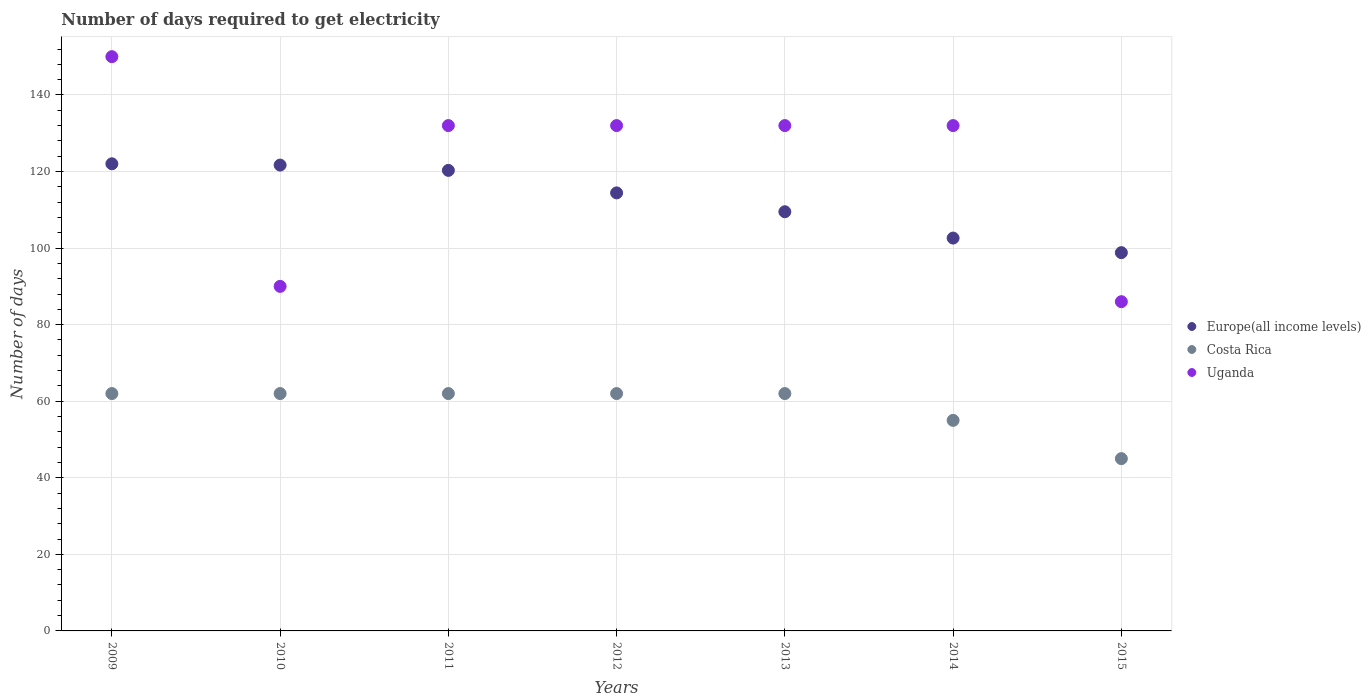What is the number of days required to get electricity in in Uganda in 2015?
Your answer should be compact. 86. Across all years, what is the maximum number of days required to get electricity in in Costa Rica?
Your response must be concise. 62. Across all years, what is the minimum number of days required to get electricity in in Europe(all income levels)?
Provide a short and direct response. 98.81. In which year was the number of days required to get electricity in in Uganda maximum?
Provide a short and direct response. 2009. In which year was the number of days required to get electricity in in Uganda minimum?
Keep it short and to the point. 2015. What is the total number of days required to get electricity in in Europe(all income levels) in the graph?
Your response must be concise. 789.33. What is the difference between the number of days required to get electricity in in Uganda in 2012 and that in 2013?
Provide a short and direct response. 0. What is the difference between the number of days required to get electricity in in Costa Rica in 2015 and the number of days required to get electricity in in Europe(all income levels) in 2010?
Offer a very short reply. -76.68. What is the average number of days required to get electricity in in Europe(all income levels) per year?
Provide a succinct answer. 112.76. In the year 2011, what is the difference between the number of days required to get electricity in in Uganda and number of days required to get electricity in in Costa Rica?
Offer a very short reply. 70. In how many years, is the number of days required to get electricity in in Costa Rica greater than 80 days?
Give a very brief answer. 0. What is the ratio of the number of days required to get electricity in in Uganda in 2010 to that in 2011?
Your answer should be compact. 0.68. Is the number of days required to get electricity in in Europe(all income levels) in 2011 less than that in 2012?
Keep it short and to the point. No. What is the difference between the highest and the second highest number of days required to get electricity in in Europe(all income levels)?
Ensure brevity in your answer.  0.34. What is the difference between the highest and the lowest number of days required to get electricity in in Europe(all income levels)?
Your answer should be very brief. 23.22. Is the sum of the number of days required to get electricity in in Europe(all income levels) in 2009 and 2014 greater than the maximum number of days required to get electricity in in Costa Rica across all years?
Your answer should be very brief. Yes. Is it the case that in every year, the sum of the number of days required to get electricity in in Costa Rica and number of days required to get electricity in in Europe(all income levels)  is greater than the number of days required to get electricity in in Uganda?
Your response must be concise. Yes. Does the number of days required to get electricity in in Uganda monotonically increase over the years?
Make the answer very short. No. How many years are there in the graph?
Your answer should be compact. 7. Are the values on the major ticks of Y-axis written in scientific E-notation?
Offer a terse response. No. Does the graph contain any zero values?
Your response must be concise. No. Where does the legend appear in the graph?
Your response must be concise. Center right. How are the legend labels stacked?
Ensure brevity in your answer.  Vertical. What is the title of the graph?
Make the answer very short. Number of days required to get electricity. What is the label or title of the Y-axis?
Your answer should be compact. Number of days. What is the Number of days of Europe(all income levels) in 2009?
Offer a very short reply. 122.02. What is the Number of days of Costa Rica in 2009?
Your answer should be compact. 62. What is the Number of days of Uganda in 2009?
Give a very brief answer. 150. What is the Number of days of Europe(all income levels) in 2010?
Give a very brief answer. 121.68. What is the Number of days of Costa Rica in 2010?
Provide a short and direct response. 62. What is the Number of days of Uganda in 2010?
Ensure brevity in your answer.  90. What is the Number of days of Europe(all income levels) in 2011?
Your answer should be very brief. 120.3. What is the Number of days in Costa Rica in 2011?
Make the answer very short. 62. What is the Number of days of Uganda in 2011?
Offer a very short reply. 132. What is the Number of days in Europe(all income levels) in 2012?
Provide a succinct answer. 114.42. What is the Number of days of Uganda in 2012?
Offer a terse response. 132. What is the Number of days in Europe(all income levels) in 2013?
Make the answer very short. 109.49. What is the Number of days of Costa Rica in 2013?
Provide a short and direct response. 62. What is the Number of days in Uganda in 2013?
Provide a short and direct response. 132. What is the Number of days in Europe(all income levels) in 2014?
Keep it short and to the point. 102.62. What is the Number of days of Costa Rica in 2014?
Your answer should be very brief. 55. What is the Number of days in Uganda in 2014?
Keep it short and to the point. 132. What is the Number of days in Europe(all income levels) in 2015?
Ensure brevity in your answer.  98.81. What is the Number of days of Uganda in 2015?
Your response must be concise. 86. Across all years, what is the maximum Number of days of Europe(all income levels)?
Ensure brevity in your answer.  122.02. Across all years, what is the maximum Number of days in Costa Rica?
Your answer should be very brief. 62. Across all years, what is the maximum Number of days of Uganda?
Provide a short and direct response. 150. Across all years, what is the minimum Number of days in Europe(all income levels)?
Your response must be concise. 98.81. Across all years, what is the minimum Number of days of Costa Rica?
Offer a terse response. 45. What is the total Number of days of Europe(all income levels) in the graph?
Your answer should be very brief. 789.33. What is the total Number of days of Costa Rica in the graph?
Keep it short and to the point. 410. What is the total Number of days in Uganda in the graph?
Provide a short and direct response. 854. What is the difference between the Number of days in Europe(all income levels) in 2009 and that in 2010?
Keep it short and to the point. 0.34. What is the difference between the Number of days of Costa Rica in 2009 and that in 2010?
Offer a very short reply. 0. What is the difference between the Number of days of Europe(all income levels) in 2009 and that in 2011?
Give a very brief answer. 1.72. What is the difference between the Number of days of Uganda in 2009 and that in 2011?
Provide a short and direct response. 18. What is the difference between the Number of days in Europe(all income levels) in 2009 and that in 2012?
Ensure brevity in your answer.  7.6. What is the difference between the Number of days in Europe(all income levels) in 2009 and that in 2013?
Ensure brevity in your answer.  12.53. What is the difference between the Number of days in Costa Rica in 2009 and that in 2013?
Offer a terse response. 0. What is the difference between the Number of days of Uganda in 2009 and that in 2013?
Your answer should be very brief. 18. What is the difference between the Number of days in Europe(all income levels) in 2009 and that in 2014?
Give a very brief answer. 19.41. What is the difference between the Number of days in Europe(all income levels) in 2009 and that in 2015?
Ensure brevity in your answer.  23.22. What is the difference between the Number of days in Europe(all income levels) in 2010 and that in 2011?
Offer a terse response. 1.38. What is the difference between the Number of days in Uganda in 2010 and that in 2011?
Keep it short and to the point. -42. What is the difference between the Number of days in Europe(all income levels) in 2010 and that in 2012?
Ensure brevity in your answer.  7.26. What is the difference between the Number of days in Costa Rica in 2010 and that in 2012?
Offer a terse response. 0. What is the difference between the Number of days in Uganda in 2010 and that in 2012?
Your answer should be compact. -42. What is the difference between the Number of days of Europe(all income levels) in 2010 and that in 2013?
Your response must be concise. 12.19. What is the difference between the Number of days in Costa Rica in 2010 and that in 2013?
Make the answer very short. 0. What is the difference between the Number of days of Uganda in 2010 and that in 2013?
Your answer should be compact. -42. What is the difference between the Number of days in Europe(all income levels) in 2010 and that in 2014?
Your answer should be very brief. 19.06. What is the difference between the Number of days in Uganda in 2010 and that in 2014?
Provide a short and direct response. -42. What is the difference between the Number of days in Europe(all income levels) in 2010 and that in 2015?
Provide a succinct answer. 22.87. What is the difference between the Number of days in Costa Rica in 2010 and that in 2015?
Offer a very short reply. 17. What is the difference between the Number of days in Europe(all income levels) in 2011 and that in 2012?
Provide a succinct answer. 5.88. What is the difference between the Number of days in Costa Rica in 2011 and that in 2012?
Provide a short and direct response. 0. What is the difference between the Number of days of Uganda in 2011 and that in 2012?
Keep it short and to the point. 0. What is the difference between the Number of days in Europe(all income levels) in 2011 and that in 2013?
Your answer should be compact. 10.8. What is the difference between the Number of days of Costa Rica in 2011 and that in 2013?
Keep it short and to the point. 0. What is the difference between the Number of days in Uganda in 2011 and that in 2013?
Ensure brevity in your answer.  0. What is the difference between the Number of days of Europe(all income levels) in 2011 and that in 2014?
Keep it short and to the point. 17.68. What is the difference between the Number of days in Costa Rica in 2011 and that in 2014?
Ensure brevity in your answer.  7. What is the difference between the Number of days of Uganda in 2011 and that in 2014?
Provide a succinct answer. 0. What is the difference between the Number of days in Europe(all income levels) in 2011 and that in 2015?
Keep it short and to the point. 21.49. What is the difference between the Number of days in Costa Rica in 2011 and that in 2015?
Make the answer very short. 17. What is the difference between the Number of days in Europe(all income levels) in 2012 and that in 2013?
Provide a short and direct response. 4.92. What is the difference between the Number of days of Costa Rica in 2012 and that in 2013?
Your response must be concise. 0. What is the difference between the Number of days in Uganda in 2012 and that in 2013?
Offer a terse response. 0. What is the difference between the Number of days of Europe(all income levels) in 2012 and that in 2014?
Offer a very short reply. 11.8. What is the difference between the Number of days in Costa Rica in 2012 and that in 2014?
Your answer should be very brief. 7. What is the difference between the Number of days of Uganda in 2012 and that in 2014?
Your answer should be compact. 0. What is the difference between the Number of days in Europe(all income levels) in 2012 and that in 2015?
Your response must be concise. 15.61. What is the difference between the Number of days of Uganda in 2012 and that in 2015?
Your answer should be compact. 46. What is the difference between the Number of days in Europe(all income levels) in 2013 and that in 2014?
Ensure brevity in your answer.  6.88. What is the difference between the Number of days in Europe(all income levels) in 2013 and that in 2015?
Your response must be concise. 10.69. What is the difference between the Number of days in Costa Rica in 2013 and that in 2015?
Your answer should be very brief. 17. What is the difference between the Number of days in Europe(all income levels) in 2014 and that in 2015?
Your answer should be very brief. 3.81. What is the difference between the Number of days of Costa Rica in 2014 and that in 2015?
Provide a succinct answer. 10. What is the difference between the Number of days of Uganda in 2014 and that in 2015?
Keep it short and to the point. 46. What is the difference between the Number of days in Europe(all income levels) in 2009 and the Number of days in Costa Rica in 2010?
Provide a succinct answer. 60.02. What is the difference between the Number of days of Europe(all income levels) in 2009 and the Number of days of Uganda in 2010?
Keep it short and to the point. 32.02. What is the difference between the Number of days of Costa Rica in 2009 and the Number of days of Uganda in 2010?
Offer a terse response. -28. What is the difference between the Number of days of Europe(all income levels) in 2009 and the Number of days of Costa Rica in 2011?
Offer a very short reply. 60.02. What is the difference between the Number of days in Europe(all income levels) in 2009 and the Number of days in Uganda in 2011?
Keep it short and to the point. -9.98. What is the difference between the Number of days of Costa Rica in 2009 and the Number of days of Uganda in 2011?
Give a very brief answer. -70. What is the difference between the Number of days in Europe(all income levels) in 2009 and the Number of days in Costa Rica in 2012?
Offer a terse response. 60.02. What is the difference between the Number of days of Europe(all income levels) in 2009 and the Number of days of Uganda in 2012?
Your answer should be very brief. -9.98. What is the difference between the Number of days of Costa Rica in 2009 and the Number of days of Uganda in 2012?
Your answer should be compact. -70. What is the difference between the Number of days in Europe(all income levels) in 2009 and the Number of days in Costa Rica in 2013?
Make the answer very short. 60.02. What is the difference between the Number of days in Europe(all income levels) in 2009 and the Number of days in Uganda in 2013?
Give a very brief answer. -9.98. What is the difference between the Number of days in Costa Rica in 2009 and the Number of days in Uganda in 2013?
Your response must be concise. -70. What is the difference between the Number of days of Europe(all income levels) in 2009 and the Number of days of Costa Rica in 2014?
Give a very brief answer. 67.02. What is the difference between the Number of days in Europe(all income levels) in 2009 and the Number of days in Uganda in 2014?
Keep it short and to the point. -9.98. What is the difference between the Number of days in Costa Rica in 2009 and the Number of days in Uganda in 2014?
Ensure brevity in your answer.  -70. What is the difference between the Number of days of Europe(all income levels) in 2009 and the Number of days of Costa Rica in 2015?
Offer a terse response. 77.02. What is the difference between the Number of days in Europe(all income levels) in 2009 and the Number of days in Uganda in 2015?
Give a very brief answer. 36.02. What is the difference between the Number of days of Costa Rica in 2009 and the Number of days of Uganda in 2015?
Your response must be concise. -24. What is the difference between the Number of days in Europe(all income levels) in 2010 and the Number of days in Costa Rica in 2011?
Offer a very short reply. 59.68. What is the difference between the Number of days of Europe(all income levels) in 2010 and the Number of days of Uganda in 2011?
Your answer should be compact. -10.32. What is the difference between the Number of days of Costa Rica in 2010 and the Number of days of Uganda in 2011?
Your answer should be very brief. -70. What is the difference between the Number of days of Europe(all income levels) in 2010 and the Number of days of Costa Rica in 2012?
Make the answer very short. 59.68. What is the difference between the Number of days in Europe(all income levels) in 2010 and the Number of days in Uganda in 2012?
Provide a succinct answer. -10.32. What is the difference between the Number of days of Costa Rica in 2010 and the Number of days of Uganda in 2012?
Your response must be concise. -70. What is the difference between the Number of days of Europe(all income levels) in 2010 and the Number of days of Costa Rica in 2013?
Offer a terse response. 59.68. What is the difference between the Number of days in Europe(all income levels) in 2010 and the Number of days in Uganda in 2013?
Provide a succinct answer. -10.32. What is the difference between the Number of days of Costa Rica in 2010 and the Number of days of Uganda in 2013?
Offer a very short reply. -70. What is the difference between the Number of days in Europe(all income levels) in 2010 and the Number of days in Costa Rica in 2014?
Ensure brevity in your answer.  66.68. What is the difference between the Number of days of Europe(all income levels) in 2010 and the Number of days of Uganda in 2014?
Your answer should be compact. -10.32. What is the difference between the Number of days of Costa Rica in 2010 and the Number of days of Uganda in 2014?
Ensure brevity in your answer.  -70. What is the difference between the Number of days of Europe(all income levels) in 2010 and the Number of days of Costa Rica in 2015?
Give a very brief answer. 76.68. What is the difference between the Number of days in Europe(all income levels) in 2010 and the Number of days in Uganda in 2015?
Provide a short and direct response. 35.68. What is the difference between the Number of days in Costa Rica in 2010 and the Number of days in Uganda in 2015?
Your response must be concise. -24. What is the difference between the Number of days in Europe(all income levels) in 2011 and the Number of days in Costa Rica in 2012?
Your response must be concise. 58.3. What is the difference between the Number of days in Europe(all income levels) in 2011 and the Number of days in Uganda in 2012?
Your answer should be very brief. -11.7. What is the difference between the Number of days in Costa Rica in 2011 and the Number of days in Uganda in 2012?
Your answer should be compact. -70. What is the difference between the Number of days of Europe(all income levels) in 2011 and the Number of days of Costa Rica in 2013?
Your answer should be compact. 58.3. What is the difference between the Number of days in Europe(all income levels) in 2011 and the Number of days in Uganda in 2013?
Your response must be concise. -11.7. What is the difference between the Number of days in Costa Rica in 2011 and the Number of days in Uganda in 2013?
Offer a very short reply. -70. What is the difference between the Number of days in Europe(all income levels) in 2011 and the Number of days in Costa Rica in 2014?
Provide a succinct answer. 65.3. What is the difference between the Number of days of Europe(all income levels) in 2011 and the Number of days of Uganda in 2014?
Provide a succinct answer. -11.7. What is the difference between the Number of days in Costa Rica in 2011 and the Number of days in Uganda in 2014?
Make the answer very short. -70. What is the difference between the Number of days in Europe(all income levels) in 2011 and the Number of days in Costa Rica in 2015?
Keep it short and to the point. 75.3. What is the difference between the Number of days of Europe(all income levels) in 2011 and the Number of days of Uganda in 2015?
Provide a succinct answer. 34.3. What is the difference between the Number of days in Costa Rica in 2011 and the Number of days in Uganda in 2015?
Your answer should be very brief. -24. What is the difference between the Number of days of Europe(all income levels) in 2012 and the Number of days of Costa Rica in 2013?
Offer a terse response. 52.42. What is the difference between the Number of days of Europe(all income levels) in 2012 and the Number of days of Uganda in 2013?
Your answer should be very brief. -17.58. What is the difference between the Number of days of Costa Rica in 2012 and the Number of days of Uganda in 2013?
Provide a succinct answer. -70. What is the difference between the Number of days of Europe(all income levels) in 2012 and the Number of days of Costa Rica in 2014?
Give a very brief answer. 59.42. What is the difference between the Number of days of Europe(all income levels) in 2012 and the Number of days of Uganda in 2014?
Provide a succinct answer. -17.58. What is the difference between the Number of days in Costa Rica in 2012 and the Number of days in Uganda in 2014?
Provide a short and direct response. -70. What is the difference between the Number of days of Europe(all income levels) in 2012 and the Number of days of Costa Rica in 2015?
Your answer should be compact. 69.42. What is the difference between the Number of days in Europe(all income levels) in 2012 and the Number of days in Uganda in 2015?
Provide a short and direct response. 28.42. What is the difference between the Number of days in Europe(all income levels) in 2013 and the Number of days in Costa Rica in 2014?
Ensure brevity in your answer.  54.49. What is the difference between the Number of days in Europe(all income levels) in 2013 and the Number of days in Uganda in 2014?
Offer a terse response. -22.51. What is the difference between the Number of days of Costa Rica in 2013 and the Number of days of Uganda in 2014?
Provide a short and direct response. -70. What is the difference between the Number of days in Europe(all income levels) in 2013 and the Number of days in Costa Rica in 2015?
Offer a very short reply. 64.49. What is the difference between the Number of days in Europe(all income levels) in 2013 and the Number of days in Uganda in 2015?
Ensure brevity in your answer.  23.49. What is the difference between the Number of days of Costa Rica in 2013 and the Number of days of Uganda in 2015?
Provide a succinct answer. -24. What is the difference between the Number of days in Europe(all income levels) in 2014 and the Number of days in Costa Rica in 2015?
Provide a short and direct response. 57.62. What is the difference between the Number of days in Europe(all income levels) in 2014 and the Number of days in Uganda in 2015?
Offer a very short reply. 16.62. What is the difference between the Number of days of Costa Rica in 2014 and the Number of days of Uganda in 2015?
Make the answer very short. -31. What is the average Number of days of Europe(all income levels) per year?
Keep it short and to the point. 112.76. What is the average Number of days in Costa Rica per year?
Make the answer very short. 58.57. What is the average Number of days of Uganda per year?
Your response must be concise. 122. In the year 2009, what is the difference between the Number of days in Europe(all income levels) and Number of days in Costa Rica?
Your response must be concise. 60.02. In the year 2009, what is the difference between the Number of days of Europe(all income levels) and Number of days of Uganda?
Give a very brief answer. -27.98. In the year 2009, what is the difference between the Number of days in Costa Rica and Number of days in Uganda?
Your answer should be compact. -88. In the year 2010, what is the difference between the Number of days of Europe(all income levels) and Number of days of Costa Rica?
Your answer should be very brief. 59.68. In the year 2010, what is the difference between the Number of days of Europe(all income levels) and Number of days of Uganda?
Offer a terse response. 31.68. In the year 2010, what is the difference between the Number of days of Costa Rica and Number of days of Uganda?
Your answer should be compact. -28. In the year 2011, what is the difference between the Number of days in Europe(all income levels) and Number of days in Costa Rica?
Give a very brief answer. 58.3. In the year 2011, what is the difference between the Number of days in Europe(all income levels) and Number of days in Uganda?
Your answer should be compact. -11.7. In the year 2011, what is the difference between the Number of days in Costa Rica and Number of days in Uganda?
Your answer should be compact. -70. In the year 2012, what is the difference between the Number of days of Europe(all income levels) and Number of days of Costa Rica?
Offer a terse response. 52.42. In the year 2012, what is the difference between the Number of days of Europe(all income levels) and Number of days of Uganda?
Your answer should be very brief. -17.58. In the year 2012, what is the difference between the Number of days in Costa Rica and Number of days in Uganda?
Your response must be concise. -70. In the year 2013, what is the difference between the Number of days of Europe(all income levels) and Number of days of Costa Rica?
Your answer should be very brief. 47.49. In the year 2013, what is the difference between the Number of days of Europe(all income levels) and Number of days of Uganda?
Ensure brevity in your answer.  -22.51. In the year 2013, what is the difference between the Number of days in Costa Rica and Number of days in Uganda?
Your response must be concise. -70. In the year 2014, what is the difference between the Number of days in Europe(all income levels) and Number of days in Costa Rica?
Make the answer very short. 47.62. In the year 2014, what is the difference between the Number of days of Europe(all income levels) and Number of days of Uganda?
Give a very brief answer. -29.38. In the year 2014, what is the difference between the Number of days of Costa Rica and Number of days of Uganda?
Offer a very short reply. -77. In the year 2015, what is the difference between the Number of days of Europe(all income levels) and Number of days of Costa Rica?
Your response must be concise. 53.81. In the year 2015, what is the difference between the Number of days of Europe(all income levels) and Number of days of Uganda?
Make the answer very short. 12.81. In the year 2015, what is the difference between the Number of days in Costa Rica and Number of days in Uganda?
Provide a short and direct response. -41. What is the ratio of the Number of days of Europe(all income levels) in 2009 to that in 2010?
Give a very brief answer. 1. What is the ratio of the Number of days of Costa Rica in 2009 to that in 2010?
Make the answer very short. 1. What is the ratio of the Number of days in Uganda in 2009 to that in 2010?
Offer a very short reply. 1.67. What is the ratio of the Number of days of Europe(all income levels) in 2009 to that in 2011?
Keep it short and to the point. 1.01. What is the ratio of the Number of days of Costa Rica in 2009 to that in 2011?
Provide a succinct answer. 1. What is the ratio of the Number of days in Uganda in 2009 to that in 2011?
Your answer should be compact. 1.14. What is the ratio of the Number of days of Europe(all income levels) in 2009 to that in 2012?
Give a very brief answer. 1.07. What is the ratio of the Number of days in Uganda in 2009 to that in 2012?
Offer a very short reply. 1.14. What is the ratio of the Number of days in Europe(all income levels) in 2009 to that in 2013?
Your response must be concise. 1.11. What is the ratio of the Number of days of Uganda in 2009 to that in 2013?
Provide a short and direct response. 1.14. What is the ratio of the Number of days of Europe(all income levels) in 2009 to that in 2014?
Ensure brevity in your answer.  1.19. What is the ratio of the Number of days in Costa Rica in 2009 to that in 2014?
Ensure brevity in your answer.  1.13. What is the ratio of the Number of days of Uganda in 2009 to that in 2014?
Make the answer very short. 1.14. What is the ratio of the Number of days of Europe(all income levels) in 2009 to that in 2015?
Your answer should be compact. 1.24. What is the ratio of the Number of days of Costa Rica in 2009 to that in 2015?
Your answer should be compact. 1.38. What is the ratio of the Number of days in Uganda in 2009 to that in 2015?
Offer a terse response. 1.74. What is the ratio of the Number of days of Europe(all income levels) in 2010 to that in 2011?
Ensure brevity in your answer.  1.01. What is the ratio of the Number of days of Costa Rica in 2010 to that in 2011?
Offer a terse response. 1. What is the ratio of the Number of days in Uganda in 2010 to that in 2011?
Ensure brevity in your answer.  0.68. What is the ratio of the Number of days of Europe(all income levels) in 2010 to that in 2012?
Keep it short and to the point. 1.06. What is the ratio of the Number of days in Costa Rica in 2010 to that in 2012?
Give a very brief answer. 1. What is the ratio of the Number of days of Uganda in 2010 to that in 2012?
Your answer should be compact. 0.68. What is the ratio of the Number of days in Europe(all income levels) in 2010 to that in 2013?
Make the answer very short. 1.11. What is the ratio of the Number of days in Uganda in 2010 to that in 2013?
Make the answer very short. 0.68. What is the ratio of the Number of days of Europe(all income levels) in 2010 to that in 2014?
Give a very brief answer. 1.19. What is the ratio of the Number of days in Costa Rica in 2010 to that in 2014?
Your answer should be compact. 1.13. What is the ratio of the Number of days of Uganda in 2010 to that in 2014?
Keep it short and to the point. 0.68. What is the ratio of the Number of days in Europe(all income levels) in 2010 to that in 2015?
Make the answer very short. 1.23. What is the ratio of the Number of days of Costa Rica in 2010 to that in 2015?
Offer a very short reply. 1.38. What is the ratio of the Number of days in Uganda in 2010 to that in 2015?
Your answer should be compact. 1.05. What is the ratio of the Number of days in Europe(all income levels) in 2011 to that in 2012?
Your response must be concise. 1.05. What is the ratio of the Number of days of Europe(all income levels) in 2011 to that in 2013?
Offer a very short reply. 1.1. What is the ratio of the Number of days of Europe(all income levels) in 2011 to that in 2014?
Make the answer very short. 1.17. What is the ratio of the Number of days in Costa Rica in 2011 to that in 2014?
Your answer should be very brief. 1.13. What is the ratio of the Number of days in Europe(all income levels) in 2011 to that in 2015?
Your answer should be very brief. 1.22. What is the ratio of the Number of days in Costa Rica in 2011 to that in 2015?
Ensure brevity in your answer.  1.38. What is the ratio of the Number of days of Uganda in 2011 to that in 2015?
Provide a succinct answer. 1.53. What is the ratio of the Number of days of Europe(all income levels) in 2012 to that in 2013?
Keep it short and to the point. 1.04. What is the ratio of the Number of days in Costa Rica in 2012 to that in 2013?
Provide a succinct answer. 1. What is the ratio of the Number of days of Europe(all income levels) in 2012 to that in 2014?
Your response must be concise. 1.11. What is the ratio of the Number of days in Costa Rica in 2012 to that in 2014?
Provide a succinct answer. 1.13. What is the ratio of the Number of days in Uganda in 2012 to that in 2014?
Give a very brief answer. 1. What is the ratio of the Number of days of Europe(all income levels) in 2012 to that in 2015?
Your response must be concise. 1.16. What is the ratio of the Number of days of Costa Rica in 2012 to that in 2015?
Ensure brevity in your answer.  1.38. What is the ratio of the Number of days of Uganda in 2012 to that in 2015?
Your answer should be compact. 1.53. What is the ratio of the Number of days of Europe(all income levels) in 2013 to that in 2014?
Make the answer very short. 1.07. What is the ratio of the Number of days of Costa Rica in 2013 to that in 2014?
Offer a very short reply. 1.13. What is the ratio of the Number of days in Uganda in 2013 to that in 2014?
Make the answer very short. 1. What is the ratio of the Number of days of Europe(all income levels) in 2013 to that in 2015?
Ensure brevity in your answer.  1.11. What is the ratio of the Number of days of Costa Rica in 2013 to that in 2015?
Give a very brief answer. 1.38. What is the ratio of the Number of days of Uganda in 2013 to that in 2015?
Offer a very short reply. 1.53. What is the ratio of the Number of days in Europe(all income levels) in 2014 to that in 2015?
Your answer should be very brief. 1.04. What is the ratio of the Number of days of Costa Rica in 2014 to that in 2015?
Offer a very short reply. 1.22. What is the ratio of the Number of days of Uganda in 2014 to that in 2015?
Offer a very short reply. 1.53. What is the difference between the highest and the second highest Number of days in Europe(all income levels)?
Make the answer very short. 0.34. What is the difference between the highest and the lowest Number of days in Europe(all income levels)?
Give a very brief answer. 23.22. 